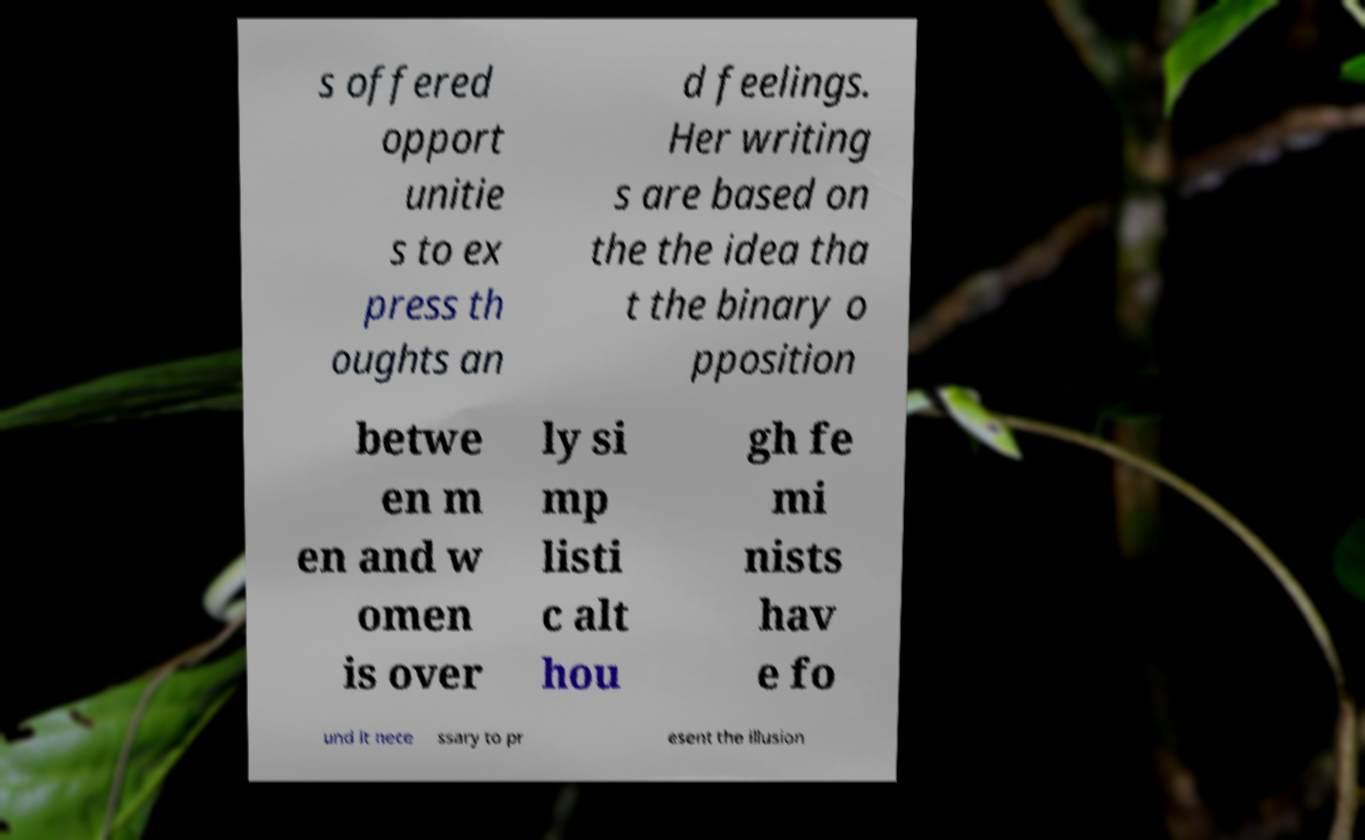Could you assist in decoding the text presented in this image and type it out clearly? s offered opport unitie s to ex press th oughts an d feelings. Her writing s are based on the the idea tha t the binary o pposition betwe en m en and w omen is over ly si mp listi c alt hou gh fe mi nists hav e fo und it nece ssary to pr esent the illusion 